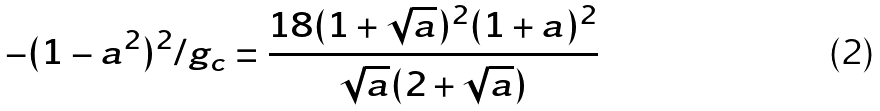<formula> <loc_0><loc_0><loc_500><loc_500>- ( 1 - a ^ { 2 } ) ^ { 2 } / g _ { c } = { \frac { 1 8 ( 1 + { \sqrt { a } } ) ^ { 2 } ( 1 + a ) ^ { 2 } } { { \sqrt { a } } ( 2 + { \sqrt { a } } ) } }</formula> 